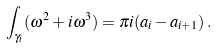Convert formula to latex. <formula><loc_0><loc_0><loc_500><loc_500>\int _ { \gamma _ { i } } ( \omega ^ { 2 } + i \omega ^ { 3 } ) = \pi i ( a _ { i } - a _ { i + 1 } ) \, .</formula> 